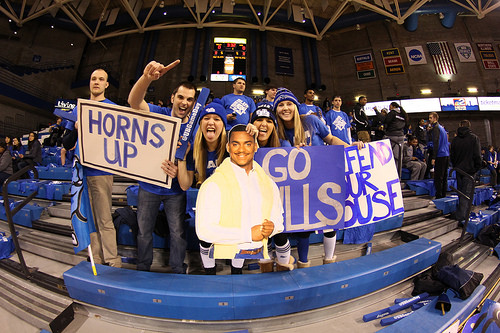<image>
Is the wall behind the girl? Yes. From this viewpoint, the wall is positioned behind the girl, with the girl partially or fully occluding the wall. Is the cardboard next to the poster? Yes. The cardboard is positioned adjacent to the poster, located nearby in the same general area. 